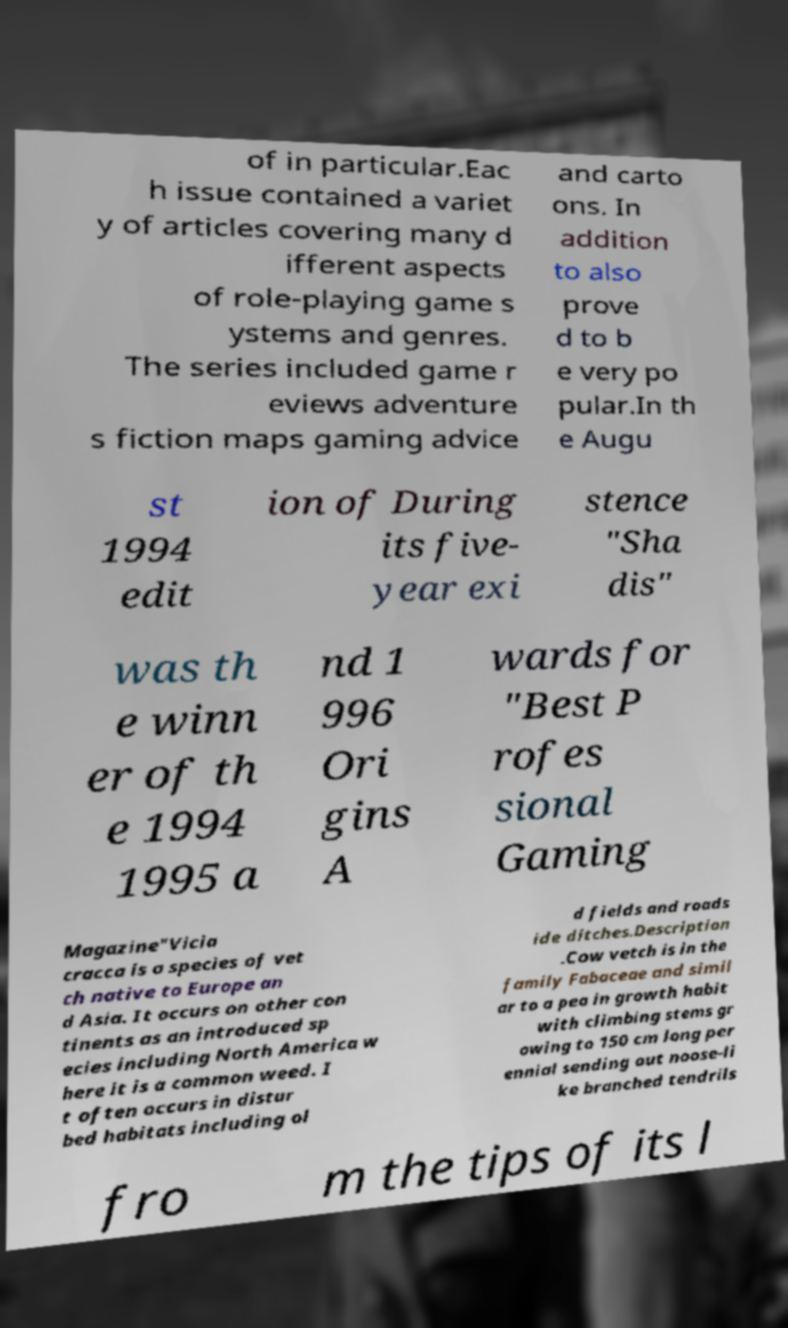Could you assist in decoding the text presented in this image and type it out clearly? of in particular.Eac h issue contained a variet y of articles covering many d ifferent aspects of role-playing game s ystems and genres. The series included game r eviews adventure s fiction maps gaming advice and carto ons. In addition to also prove d to b e very po pular.In th e Augu st 1994 edit ion of During its five- year exi stence "Sha dis" was th e winn er of th e 1994 1995 a nd 1 996 Ori gins A wards for "Best P rofes sional Gaming Magazine"Vicia cracca is a species of vet ch native to Europe an d Asia. It occurs on other con tinents as an introduced sp ecies including North America w here it is a common weed. I t often occurs in distur bed habitats including ol d fields and roads ide ditches.Description .Cow vetch is in the family Fabaceae and simil ar to a pea in growth habit with climbing stems gr owing to 150 cm long per ennial sending out noose-li ke branched tendrils fro m the tips of its l 